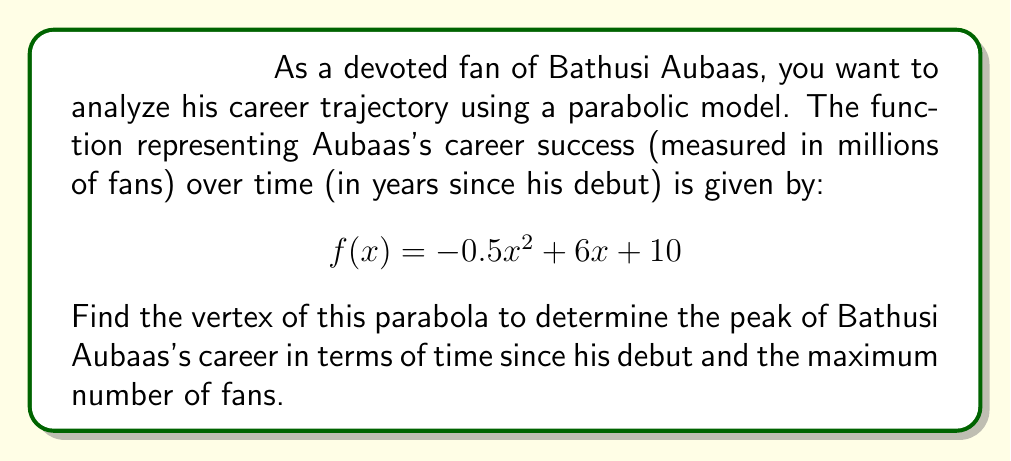Solve this math problem. To find the vertex of the parabola, we'll follow these steps:

1) The general form of a quadratic function is $f(x) = ax^2 + bx + c$. In this case:
   $a = -0.5$, $b = 6$, and $c = 10$

2) For a parabola in the form $f(x) = a(x-h)^2 + k$, the vertex is $(h,k)$.

3) To find $h$ (the x-coordinate of the vertex), we use the formula:
   $$h = -\frac{b}{2a}$$

4) Substituting our values:
   $$h = -\frac{6}{2(-0.5)} = -\frac{6}{-1} = 6$$

5) To find $k$ (the y-coordinate of the vertex), we substitute $x=h$ into the original function:
   $$\begin{align}
   k = f(6) &= -0.5(6)^2 + 6(6) + 10 \\
            &= -0.5(36) + 36 + 10 \\
            &= -18 + 36 + 10 \\
            &= 28
   \end{align}$$

6) Therefore, the vertex is $(6, 28)$.

This means that Bathusi Aubaas's career peaked 6 years after his debut, with a maximum of 28 million fans.
Answer: The vertex of the parabola is $(6, 28)$. 